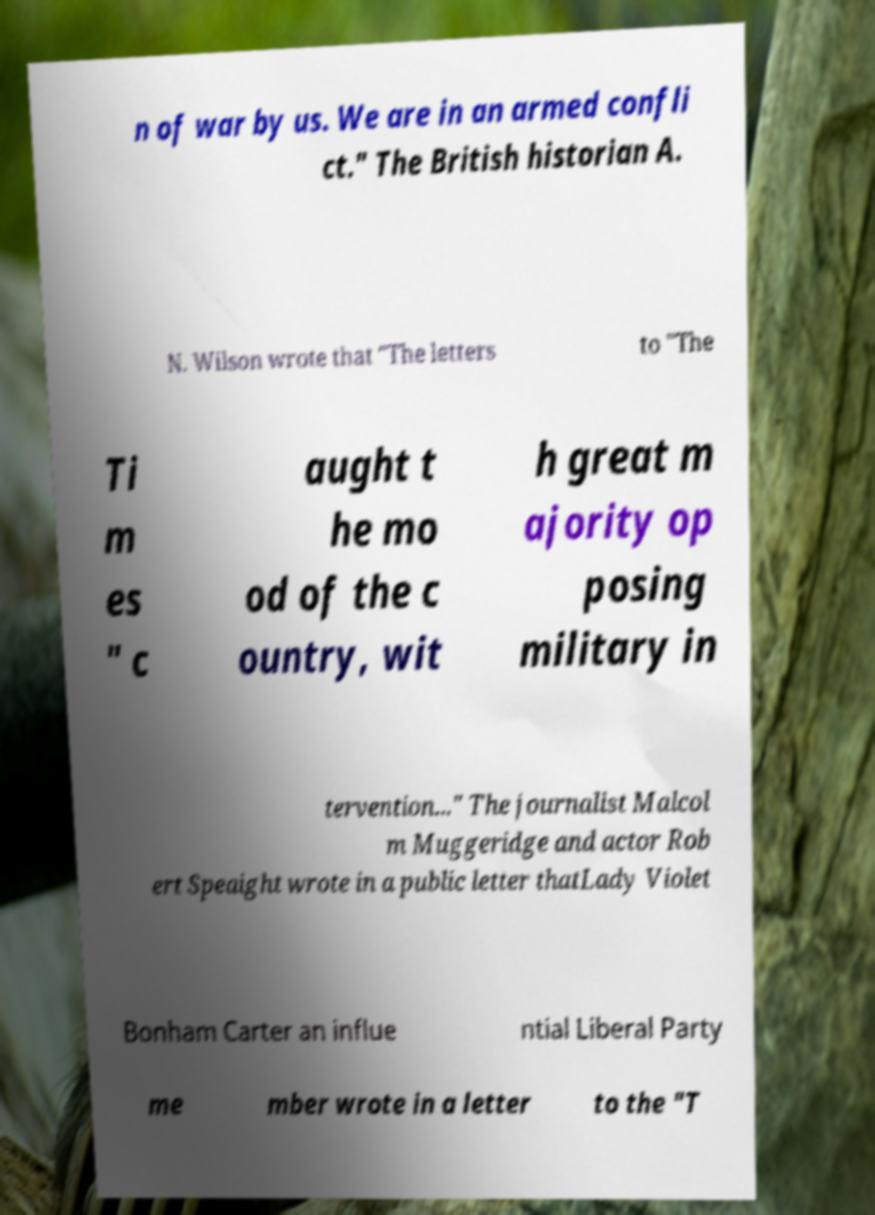Can you read and provide the text displayed in the image?This photo seems to have some interesting text. Can you extract and type it out for me? n of war by us. We are in an armed confli ct." The British historian A. N. Wilson wrote that "The letters to "The Ti m es " c aught t he mo od of the c ountry, wit h great m ajority op posing military in tervention..." The journalist Malcol m Muggeridge and actor Rob ert Speaight wrote in a public letter thatLady Violet Bonham Carter an influe ntial Liberal Party me mber wrote in a letter to the "T 